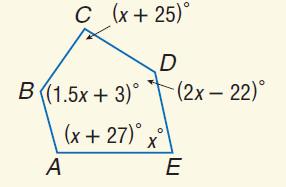Question: Find m \angle C.
Choices:
A. 78
B. 103
C. 105
D. 120
Answer with the letter. Answer: B Question: Find m \angle B.
Choices:
A. 78
B. 103
C. 105
D. 120
Answer with the letter. Answer: D Question: Find m \angle E.
Choices:
A. 78
B. 102
C. 103
D. 134
Answer with the letter. Answer: A 